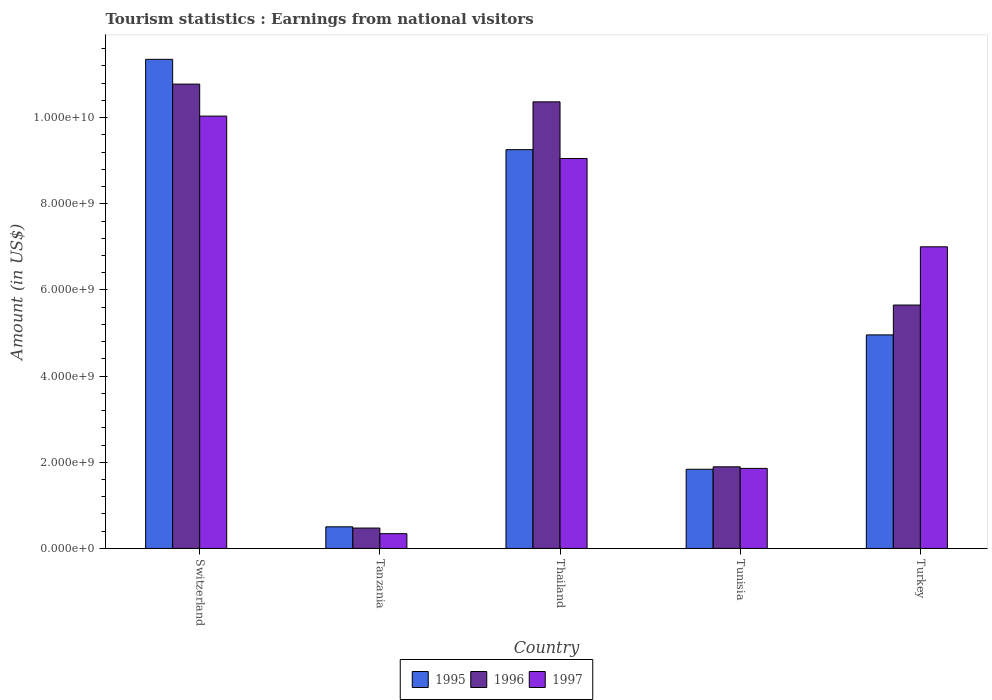Are the number of bars on each tick of the X-axis equal?
Ensure brevity in your answer.  Yes. How many bars are there on the 4th tick from the left?
Make the answer very short. 3. How many bars are there on the 3rd tick from the right?
Your response must be concise. 3. What is the label of the 5th group of bars from the left?
Make the answer very short. Turkey. In how many cases, is the number of bars for a given country not equal to the number of legend labels?
Make the answer very short. 0. What is the earnings from national visitors in 1997 in Thailand?
Ensure brevity in your answer.  9.05e+09. Across all countries, what is the maximum earnings from national visitors in 1996?
Your answer should be compact. 1.08e+1. Across all countries, what is the minimum earnings from national visitors in 1996?
Keep it short and to the point. 4.73e+08. In which country was the earnings from national visitors in 1997 maximum?
Offer a terse response. Switzerland. In which country was the earnings from national visitors in 1997 minimum?
Provide a short and direct response. Tanzania. What is the total earnings from national visitors in 1997 in the graph?
Offer a terse response. 2.83e+1. What is the difference between the earnings from national visitors in 1996 in Tunisia and that in Turkey?
Offer a very short reply. -3.76e+09. What is the difference between the earnings from national visitors in 1997 in Tunisia and the earnings from national visitors in 1996 in Thailand?
Your response must be concise. -8.51e+09. What is the average earnings from national visitors in 1996 per country?
Offer a terse response. 5.83e+09. What is the difference between the earnings from national visitors of/in 1995 and earnings from national visitors of/in 1997 in Turkey?
Keep it short and to the point. -2.04e+09. What is the ratio of the earnings from national visitors in 1995 in Switzerland to that in Tanzania?
Your response must be concise. 22.62. Is the earnings from national visitors in 1995 in Thailand less than that in Turkey?
Offer a terse response. No. What is the difference between the highest and the second highest earnings from national visitors in 1995?
Offer a terse response. 2.10e+09. What is the difference between the highest and the lowest earnings from national visitors in 1997?
Provide a short and direct response. 9.69e+09. In how many countries, is the earnings from national visitors in 1997 greater than the average earnings from national visitors in 1997 taken over all countries?
Ensure brevity in your answer.  3. What does the 1st bar from the right in Turkey represents?
Offer a terse response. 1997. What is the difference between two consecutive major ticks on the Y-axis?
Your answer should be compact. 2.00e+09. Does the graph contain any zero values?
Your answer should be very brief. No. Where does the legend appear in the graph?
Offer a very short reply. Bottom center. How are the legend labels stacked?
Offer a very short reply. Horizontal. What is the title of the graph?
Give a very brief answer. Tourism statistics : Earnings from national visitors. What is the label or title of the Y-axis?
Your answer should be very brief. Amount (in US$). What is the Amount (in US$) in 1995 in Switzerland?
Offer a very short reply. 1.14e+1. What is the Amount (in US$) of 1996 in Switzerland?
Give a very brief answer. 1.08e+1. What is the Amount (in US$) of 1997 in Switzerland?
Offer a terse response. 1.00e+1. What is the Amount (in US$) in 1995 in Tanzania?
Your response must be concise. 5.02e+08. What is the Amount (in US$) of 1996 in Tanzania?
Give a very brief answer. 4.73e+08. What is the Amount (in US$) of 1997 in Tanzania?
Offer a terse response. 3.43e+08. What is the Amount (in US$) of 1995 in Thailand?
Your answer should be compact. 9.26e+09. What is the Amount (in US$) in 1996 in Thailand?
Keep it short and to the point. 1.04e+1. What is the Amount (in US$) in 1997 in Thailand?
Offer a very short reply. 9.05e+09. What is the Amount (in US$) of 1995 in Tunisia?
Give a very brief answer. 1.84e+09. What is the Amount (in US$) in 1996 in Tunisia?
Your answer should be compact. 1.90e+09. What is the Amount (in US$) of 1997 in Tunisia?
Your response must be concise. 1.86e+09. What is the Amount (in US$) of 1995 in Turkey?
Make the answer very short. 4.96e+09. What is the Amount (in US$) in 1996 in Turkey?
Your response must be concise. 5.65e+09. What is the Amount (in US$) of 1997 in Turkey?
Offer a very short reply. 7.00e+09. Across all countries, what is the maximum Amount (in US$) in 1995?
Your response must be concise. 1.14e+1. Across all countries, what is the maximum Amount (in US$) of 1996?
Ensure brevity in your answer.  1.08e+1. Across all countries, what is the maximum Amount (in US$) in 1997?
Ensure brevity in your answer.  1.00e+1. Across all countries, what is the minimum Amount (in US$) in 1995?
Give a very brief answer. 5.02e+08. Across all countries, what is the minimum Amount (in US$) of 1996?
Offer a terse response. 4.73e+08. Across all countries, what is the minimum Amount (in US$) in 1997?
Your answer should be compact. 3.43e+08. What is the total Amount (in US$) of 1995 in the graph?
Offer a very short reply. 2.79e+1. What is the total Amount (in US$) of 1996 in the graph?
Your response must be concise. 2.92e+1. What is the total Amount (in US$) of 1997 in the graph?
Ensure brevity in your answer.  2.83e+1. What is the difference between the Amount (in US$) of 1995 in Switzerland and that in Tanzania?
Ensure brevity in your answer.  1.09e+1. What is the difference between the Amount (in US$) in 1996 in Switzerland and that in Tanzania?
Keep it short and to the point. 1.03e+1. What is the difference between the Amount (in US$) of 1997 in Switzerland and that in Tanzania?
Offer a terse response. 9.69e+09. What is the difference between the Amount (in US$) in 1995 in Switzerland and that in Thailand?
Offer a terse response. 2.10e+09. What is the difference between the Amount (in US$) of 1996 in Switzerland and that in Thailand?
Ensure brevity in your answer.  4.12e+08. What is the difference between the Amount (in US$) of 1997 in Switzerland and that in Thailand?
Give a very brief answer. 9.84e+08. What is the difference between the Amount (in US$) in 1995 in Switzerland and that in Tunisia?
Give a very brief answer. 9.52e+09. What is the difference between the Amount (in US$) in 1996 in Switzerland and that in Tunisia?
Your answer should be compact. 8.88e+09. What is the difference between the Amount (in US$) of 1997 in Switzerland and that in Tunisia?
Provide a short and direct response. 8.18e+09. What is the difference between the Amount (in US$) in 1995 in Switzerland and that in Turkey?
Make the answer very short. 6.40e+09. What is the difference between the Amount (in US$) of 1996 in Switzerland and that in Turkey?
Offer a terse response. 5.13e+09. What is the difference between the Amount (in US$) in 1997 in Switzerland and that in Turkey?
Your response must be concise. 3.03e+09. What is the difference between the Amount (in US$) of 1995 in Tanzania and that in Thailand?
Provide a short and direct response. -8.76e+09. What is the difference between the Amount (in US$) of 1996 in Tanzania and that in Thailand?
Provide a short and direct response. -9.89e+09. What is the difference between the Amount (in US$) in 1997 in Tanzania and that in Thailand?
Provide a succinct answer. -8.71e+09. What is the difference between the Amount (in US$) in 1995 in Tanzania and that in Tunisia?
Provide a short and direct response. -1.34e+09. What is the difference between the Amount (in US$) of 1996 in Tanzania and that in Tunisia?
Your answer should be very brief. -1.42e+09. What is the difference between the Amount (in US$) of 1997 in Tanzania and that in Tunisia?
Offer a very short reply. -1.52e+09. What is the difference between the Amount (in US$) of 1995 in Tanzania and that in Turkey?
Provide a succinct answer. -4.46e+09. What is the difference between the Amount (in US$) in 1996 in Tanzania and that in Turkey?
Make the answer very short. -5.18e+09. What is the difference between the Amount (in US$) of 1997 in Tanzania and that in Turkey?
Provide a succinct answer. -6.66e+09. What is the difference between the Amount (in US$) in 1995 in Thailand and that in Tunisia?
Your response must be concise. 7.42e+09. What is the difference between the Amount (in US$) of 1996 in Thailand and that in Tunisia?
Your answer should be compact. 8.47e+09. What is the difference between the Amount (in US$) in 1997 in Thailand and that in Tunisia?
Your answer should be very brief. 7.19e+09. What is the difference between the Amount (in US$) of 1995 in Thailand and that in Turkey?
Your response must be concise. 4.30e+09. What is the difference between the Amount (in US$) in 1996 in Thailand and that in Turkey?
Offer a very short reply. 4.72e+09. What is the difference between the Amount (in US$) in 1997 in Thailand and that in Turkey?
Your answer should be compact. 2.05e+09. What is the difference between the Amount (in US$) in 1995 in Tunisia and that in Turkey?
Give a very brief answer. -3.12e+09. What is the difference between the Amount (in US$) of 1996 in Tunisia and that in Turkey?
Provide a succinct answer. -3.76e+09. What is the difference between the Amount (in US$) in 1997 in Tunisia and that in Turkey?
Give a very brief answer. -5.14e+09. What is the difference between the Amount (in US$) in 1995 in Switzerland and the Amount (in US$) in 1996 in Tanzania?
Ensure brevity in your answer.  1.09e+1. What is the difference between the Amount (in US$) in 1995 in Switzerland and the Amount (in US$) in 1997 in Tanzania?
Make the answer very short. 1.10e+1. What is the difference between the Amount (in US$) in 1996 in Switzerland and the Amount (in US$) in 1997 in Tanzania?
Provide a succinct answer. 1.04e+1. What is the difference between the Amount (in US$) in 1995 in Switzerland and the Amount (in US$) in 1996 in Thailand?
Your response must be concise. 9.87e+08. What is the difference between the Amount (in US$) of 1995 in Switzerland and the Amount (in US$) of 1997 in Thailand?
Your answer should be very brief. 2.30e+09. What is the difference between the Amount (in US$) in 1996 in Switzerland and the Amount (in US$) in 1997 in Thailand?
Offer a very short reply. 1.73e+09. What is the difference between the Amount (in US$) in 1995 in Switzerland and the Amount (in US$) in 1996 in Tunisia?
Ensure brevity in your answer.  9.46e+09. What is the difference between the Amount (in US$) in 1995 in Switzerland and the Amount (in US$) in 1997 in Tunisia?
Keep it short and to the point. 9.50e+09. What is the difference between the Amount (in US$) of 1996 in Switzerland and the Amount (in US$) of 1997 in Tunisia?
Provide a short and direct response. 8.92e+09. What is the difference between the Amount (in US$) of 1995 in Switzerland and the Amount (in US$) of 1996 in Turkey?
Offer a very short reply. 5.70e+09. What is the difference between the Amount (in US$) in 1995 in Switzerland and the Amount (in US$) in 1997 in Turkey?
Provide a succinct answer. 4.35e+09. What is the difference between the Amount (in US$) of 1996 in Switzerland and the Amount (in US$) of 1997 in Turkey?
Ensure brevity in your answer.  3.78e+09. What is the difference between the Amount (in US$) in 1995 in Tanzania and the Amount (in US$) in 1996 in Thailand?
Make the answer very short. -9.86e+09. What is the difference between the Amount (in US$) in 1995 in Tanzania and the Amount (in US$) in 1997 in Thailand?
Offer a terse response. -8.55e+09. What is the difference between the Amount (in US$) of 1996 in Tanzania and the Amount (in US$) of 1997 in Thailand?
Provide a succinct answer. -8.58e+09. What is the difference between the Amount (in US$) of 1995 in Tanzania and the Amount (in US$) of 1996 in Tunisia?
Ensure brevity in your answer.  -1.39e+09. What is the difference between the Amount (in US$) of 1995 in Tanzania and the Amount (in US$) of 1997 in Tunisia?
Provide a succinct answer. -1.36e+09. What is the difference between the Amount (in US$) of 1996 in Tanzania and the Amount (in US$) of 1997 in Tunisia?
Make the answer very short. -1.38e+09. What is the difference between the Amount (in US$) of 1995 in Tanzania and the Amount (in US$) of 1996 in Turkey?
Your answer should be compact. -5.15e+09. What is the difference between the Amount (in US$) of 1995 in Tanzania and the Amount (in US$) of 1997 in Turkey?
Your answer should be compact. -6.50e+09. What is the difference between the Amount (in US$) of 1996 in Tanzania and the Amount (in US$) of 1997 in Turkey?
Provide a succinct answer. -6.53e+09. What is the difference between the Amount (in US$) of 1995 in Thailand and the Amount (in US$) of 1996 in Tunisia?
Offer a very short reply. 7.36e+09. What is the difference between the Amount (in US$) in 1995 in Thailand and the Amount (in US$) in 1997 in Tunisia?
Offer a very short reply. 7.40e+09. What is the difference between the Amount (in US$) in 1996 in Thailand and the Amount (in US$) in 1997 in Tunisia?
Give a very brief answer. 8.51e+09. What is the difference between the Amount (in US$) in 1995 in Thailand and the Amount (in US$) in 1996 in Turkey?
Ensure brevity in your answer.  3.61e+09. What is the difference between the Amount (in US$) in 1995 in Thailand and the Amount (in US$) in 1997 in Turkey?
Your answer should be compact. 2.26e+09. What is the difference between the Amount (in US$) of 1996 in Thailand and the Amount (in US$) of 1997 in Turkey?
Ensure brevity in your answer.  3.36e+09. What is the difference between the Amount (in US$) of 1995 in Tunisia and the Amount (in US$) of 1996 in Turkey?
Ensure brevity in your answer.  -3.81e+09. What is the difference between the Amount (in US$) of 1995 in Tunisia and the Amount (in US$) of 1997 in Turkey?
Provide a short and direct response. -5.16e+09. What is the difference between the Amount (in US$) of 1996 in Tunisia and the Amount (in US$) of 1997 in Turkey?
Offer a terse response. -5.11e+09. What is the average Amount (in US$) in 1995 per country?
Keep it short and to the point. 5.58e+09. What is the average Amount (in US$) in 1996 per country?
Ensure brevity in your answer.  5.83e+09. What is the average Amount (in US$) in 1997 per country?
Your answer should be compact. 5.66e+09. What is the difference between the Amount (in US$) of 1995 and Amount (in US$) of 1996 in Switzerland?
Provide a short and direct response. 5.75e+08. What is the difference between the Amount (in US$) of 1995 and Amount (in US$) of 1997 in Switzerland?
Make the answer very short. 1.32e+09. What is the difference between the Amount (in US$) in 1996 and Amount (in US$) in 1997 in Switzerland?
Offer a terse response. 7.43e+08. What is the difference between the Amount (in US$) of 1995 and Amount (in US$) of 1996 in Tanzania?
Provide a succinct answer. 2.90e+07. What is the difference between the Amount (in US$) of 1995 and Amount (in US$) of 1997 in Tanzania?
Provide a succinct answer. 1.59e+08. What is the difference between the Amount (in US$) in 1996 and Amount (in US$) in 1997 in Tanzania?
Give a very brief answer. 1.30e+08. What is the difference between the Amount (in US$) in 1995 and Amount (in US$) in 1996 in Thailand?
Your answer should be very brief. -1.11e+09. What is the difference between the Amount (in US$) of 1995 and Amount (in US$) of 1997 in Thailand?
Keep it short and to the point. 2.05e+08. What is the difference between the Amount (in US$) in 1996 and Amount (in US$) in 1997 in Thailand?
Give a very brief answer. 1.32e+09. What is the difference between the Amount (in US$) of 1995 and Amount (in US$) of 1996 in Tunisia?
Provide a short and direct response. -5.70e+07. What is the difference between the Amount (in US$) in 1995 and Amount (in US$) in 1997 in Tunisia?
Give a very brief answer. -2.00e+07. What is the difference between the Amount (in US$) in 1996 and Amount (in US$) in 1997 in Tunisia?
Provide a short and direct response. 3.70e+07. What is the difference between the Amount (in US$) in 1995 and Amount (in US$) in 1996 in Turkey?
Provide a succinct answer. -6.93e+08. What is the difference between the Amount (in US$) in 1995 and Amount (in US$) in 1997 in Turkey?
Make the answer very short. -2.04e+09. What is the difference between the Amount (in US$) of 1996 and Amount (in US$) of 1997 in Turkey?
Your answer should be compact. -1.35e+09. What is the ratio of the Amount (in US$) of 1995 in Switzerland to that in Tanzania?
Make the answer very short. 22.62. What is the ratio of the Amount (in US$) of 1996 in Switzerland to that in Tanzania?
Provide a succinct answer. 22.79. What is the ratio of the Amount (in US$) of 1997 in Switzerland to that in Tanzania?
Provide a succinct answer. 29.26. What is the ratio of the Amount (in US$) of 1995 in Switzerland to that in Thailand?
Your answer should be compact. 1.23. What is the ratio of the Amount (in US$) of 1996 in Switzerland to that in Thailand?
Make the answer very short. 1.04. What is the ratio of the Amount (in US$) of 1997 in Switzerland to that in Thailand?
Your answer should be compact. 1.11. What is the ratio of the Amount (in US$) in 1995 in Switzerland to that in Tunisia?
Provide a short and direct response. 6.18. What is the ratio of the Amount (in US$) of 1996 in Switzerland to that in Tunisia?
Make the answer very short. 5.69. What is the ratio of the Amount (in US$) of 1997 in Switzerland to that in Tunisia?
Provide a succinct answer. 5.4. What is the ratio of the Amount (in US$) of 1995 in Switzerland to that in Turkey?
Ensure brevity in your answer.  2.29. What is the ratio of the Amount (in US$) of 1996 in Switzerland to that in Turkey?
Provide a short and direct response. 1.91. What is the ratio of the Amount (in US$) in 1997 in Switzerland to that in Turkey?
Your answer should be very brief. 1.43. What is the ratio of the Amount (in US$) of 1995 in Tanzania to that in Thailand?
Offer a very short reply. 0.05. What is the ratio of the Amount (in US$) in 1996 in Tanzania to that in Thailand?
Provide a short and direct response. 0.05. What is the ratio of the Amount (in US$) of 1997 in Tanzania to that in Thailand?
Provide a short and direct response. 0.04. What is the ratio of the Amount (in US$) in 1995 in Tanzania to that in Tunisia?
Give a very brief answer. 0.27. What is the ratio of the Amount (in US$) in 1996 in Tanzania to that in Tunisia?
Your answer should be very brief. 0.25. What is the ratio of the Amount (in US$) of 1997 in Tanzania to that in Tunisia?
Your response must be concise. 0.18. What is the ratio of the Amount (in US$) of 1995 in Tanzania to that in Turkey?
Your answer should be very brief. 0.1. What is the ratio of the Amount (in US$) in 1996 in Tanzania to that in Turkey?
Make the answer very short. 0.08. What is the ratio of the Amount (in US$) in 1997 in Tanzania to that in Turkey?
Your answer should be very brief. 0.05. What is the ratio of the Amount (in US$) in 1995 in Thailand to that in Tunisia?
Your response must be concise. 5.04. What is the ratio of the Amount (in US$) of 1996 in Thailand to that in Tunisia?
Offer a very short reply. 5.47. What is the ratio of the Amount (in US$) of 1997 in Thailand to that in Tunisia?
Your answer should be very brief. 4.87. What is the ratio of the Amount (in US$) in 1995 in Thailand to that in Turkey?
Offer a very short reply. 1.87. What is the ratio of the Amount (in US$) in 1996 in Thailand to that in Turkey?
Offer a terse response. 1.83. What is the ratio of the Amount (in US$) in 1997 in Thailand to that in Turkey?
Keep it short and to the point. 1.29. What is the ratio of the Amount (in US$) in 1995 in Tunisia to that in Turkey?
Give a very brief answer. 0.37. What is the ratio of the Amount (in US$) of 1996 in Tunisia to that in Turkey?
Keep it short and to the point. 0.34. What is the ratio of the Amount (in US$) of 1997 in Tunisia to that in Turkey?
Your answer should be very brief. 0.27. What is the difference between the highest and the second highest Amount (in US$) of 1995?
Ensure brevity in your answer.  2.10e+09. What is the difference between the highest and the second highest Amount (in US$) of 1996?
Keep it short and to the point. 4.12e+08. What is the difference between the highest and the second highest Amount (in US$) of 1997?
Make the answer very short. 9.84e+08. What is the difference between the highest and the lowest Amount (in US$) of 1995?
Provide a short and direct response. 1.09e+1. What is the difference between the highest and the lowest Amount (in US$) of 1996?
Offer a terse response. 1.03e+1. What is the difference between the highest and the lowest Amount (in US$) in 1997?
Keep it short and to the point. 9.69e+09. 